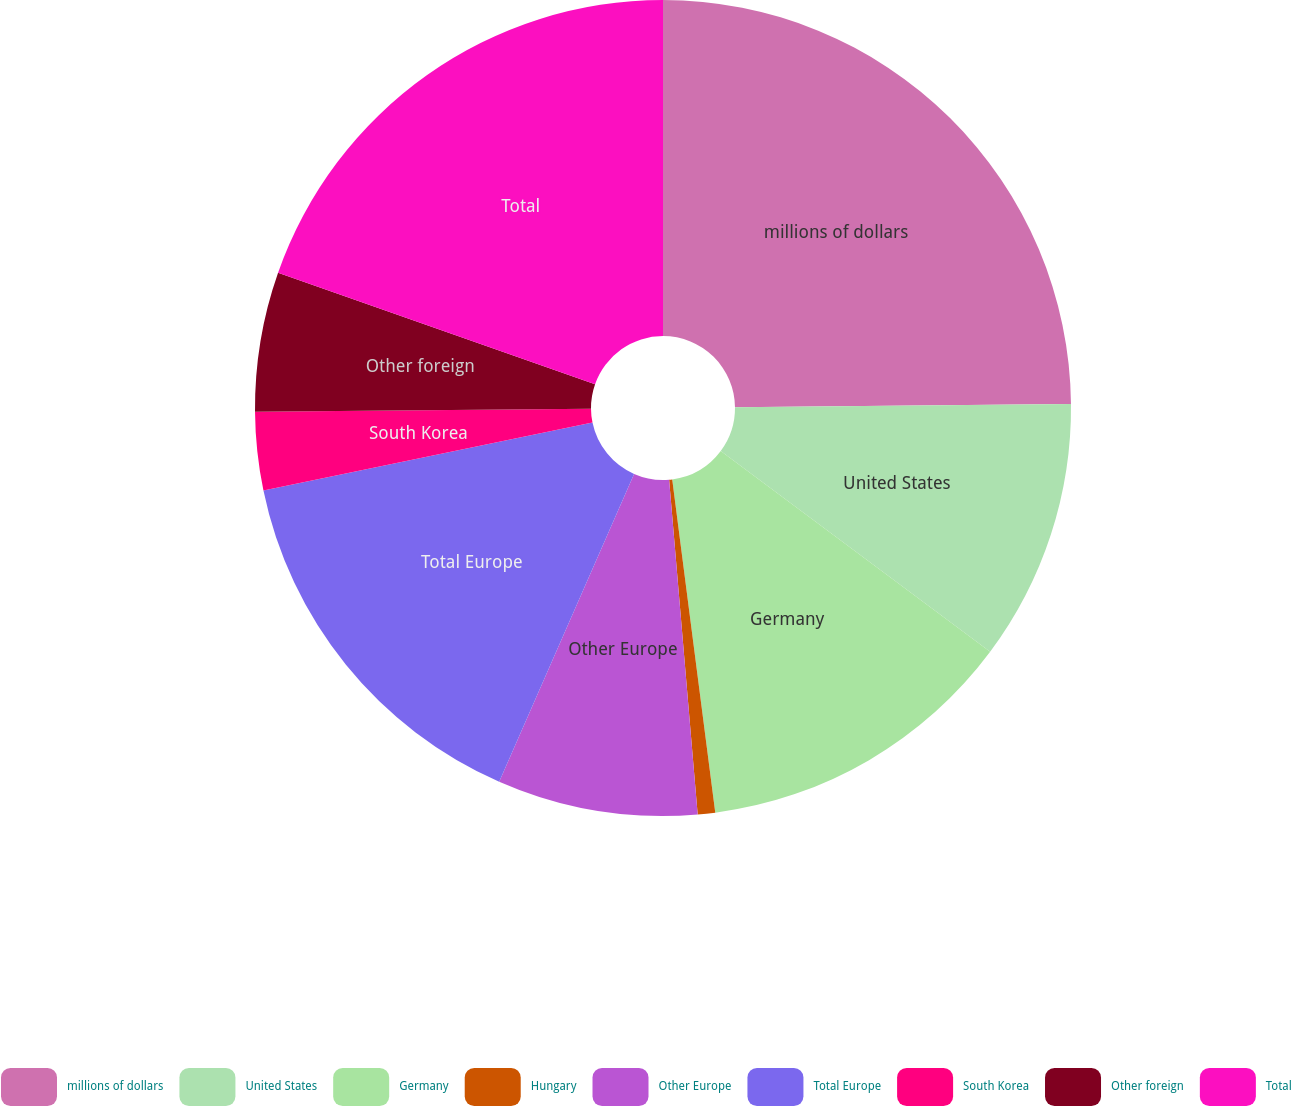Convert chart to OTSL. <chart><loc_0><loc_0><loc_500><loc_500><pie_chart><fcel>millions of dollars<fcel>United States<fcel>Germany<fcel>Hungary<fcel>Other Europe<fcel>Total Europe<fcel>South Korea<fcel>Other foreign<fcel>Total<nl><fcel>24.84%<fcel>10.35%<fcel>12.76%<fcel>0.69%<fcel>7.93%<fcel>15.18%<fcel>3.1%<fcel>5.52%<fcel>19.62%<nl></chart> 